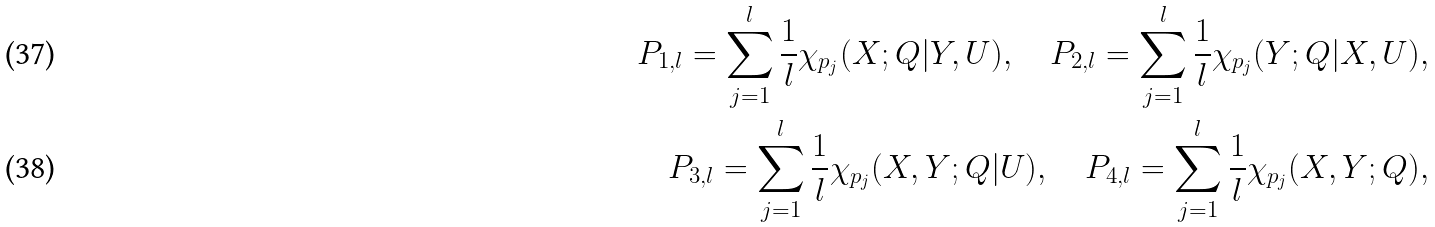Convert formula to latex. <formula><loc_0><loc_0><loc_500><loc_500>P _ { 1 , l } = \sum _ { j = 1 } ^ { l } \frac { 1 } { l } \chi _ { p _ { j } } ( X ; Q | Y , U ) , \quad P _ { 2 , l } = \sum _ { j = 1 } ^ { l } \frac { 1 } { l } \chi _ { p _ { j } } ( Y ; Q | X , U ) , \\ P _ { 3 , l } = \sum _ { j = 1 } ^ { l } \frac { 1 } { l } \chi _ { p _ { j } } ( X , Y ; Q | U ) , \quad P _ { 4 , l } = \sum _ { j = 1 } ^ { l } \frac { 1 } { l } \chi _ { p _ { j } } ( X , Y ; Q ) ,</formula> 